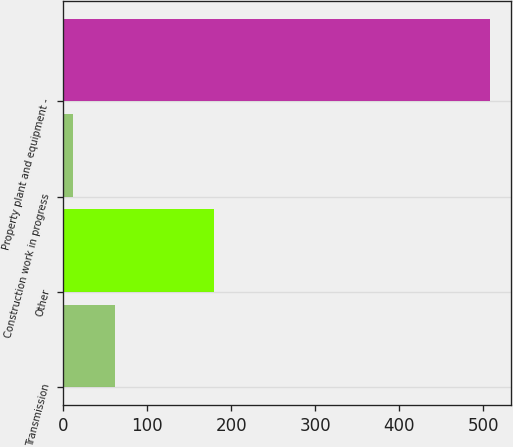Convert chart to OTSL. <chart><loc_0><loc_0><loc_500><loc_500><bar_chart><fcel>Transmission<fcel>Other<fcel>Construction work in progress<fcel>Property plant and equipment -<nl><fcel>61.6<fcel>180<fcel>12<fcel>508<nl></chart> 